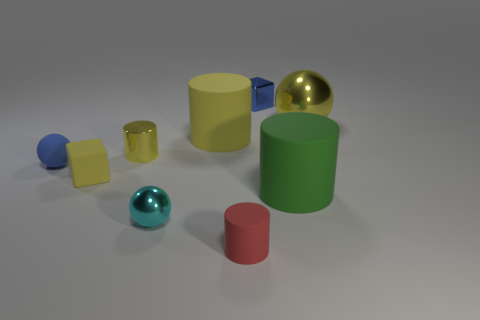Subtract all small yellow cylinders. How many cylinders are left? 3 Subtract 2 cylinders. How many cylinders are left? 2 Subtract all yellow balls. How many balls are left? 2 Subtract all cubes. How many objects are left? 7 Add 1 large yellow shiny things. How many large yellow shiny things are left? 2 Add 2 blue matte spheres. How many blue matte spheres exist? 3 Subtract 1 cyan spheres. How many objects are left? 8 Subtract all blue blocks. Subtract all yellow cylinders. How many blocks are left? 1 Subtract all red balls. How many green cylinders are left? 1 Subtract all tiny blue spheres. Subtract all small green cubes. How many objects are left? 8 